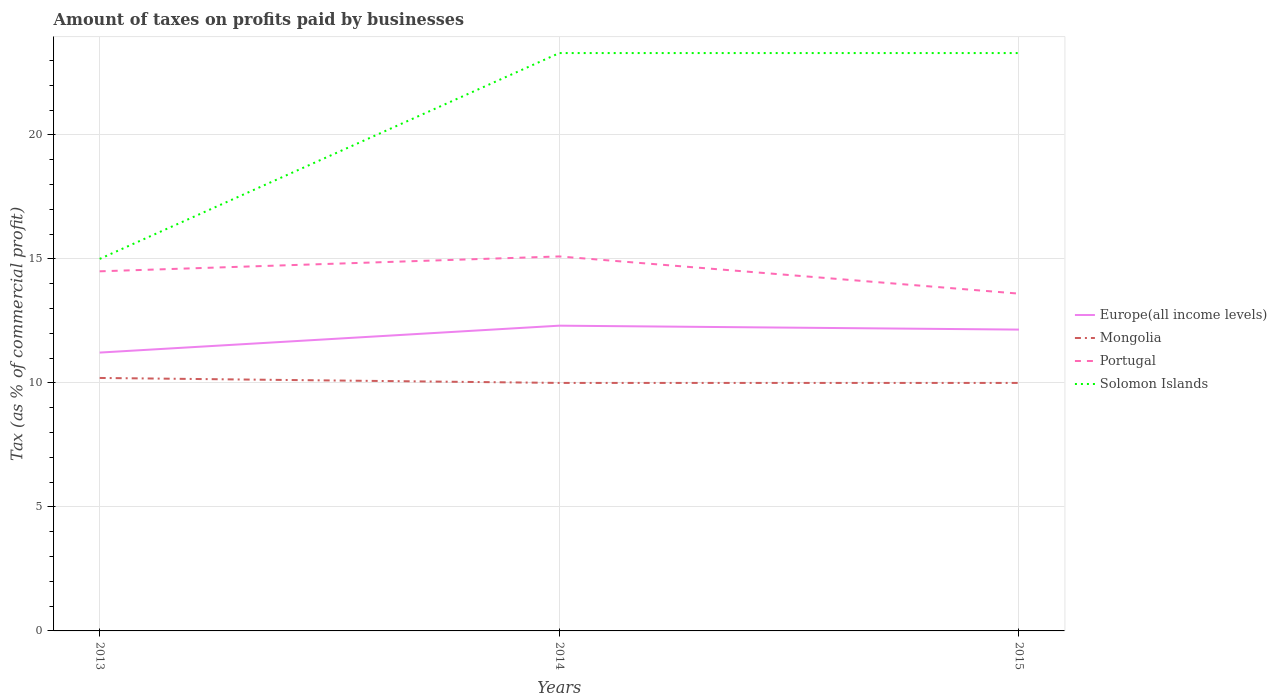Is the number of lines equal to the number of legend labels?
Offer a terse response. Yes. In which year was the percentage of taxes paid by businesses in Mongolia maximum?
Provide a short and direct response. 2014. What is the total percentage of taxes paid by businesses in Mongolia in the graph?
Give a very brief answer. 0.2. What is the difference between the highest and the second highest percentage of taxes paid by businesses in Mongolia?
Offer a terse response. 0.2. Is the percentage of taxes paid by businesses in Solomon Islands strictly greater than the percentage of taxes paid by businesses in Europe(all income levels) over the years?
Ensure brevity in your answer.  No. How many lines are there?
Provide a succinct answer. 4. How many years are there in the graph?
Your response must be concise. 3. What is the difference between two consecutive major ticks on the Y-axis?
Make the answer very short. 5. Are the values on the major ticks of Y-axis written in scientific E-notation?
Your answer should be compact. No. Does the graph contain any zero values?
Keep it short and to the point. No. How many legend labels are there?
Offer a terse response. 4. What is the title of the graph?
Your answer should be very brief. Amount of taxes on profits paid by businesses. What is the label or title of the X-axis?
Offer a terse response. Years. What is the label or title of the Y-axis?
Make the answer very short. Tax (as % of commercial profit). What is the Tax (as % of commercial profit) in Europe(all income levels) in 2013?
Provide a succinct answer. 11.22. What is the Tax (as % of commercial profit) of Portugal in 2013?
Provide a short and direct response. 14.5. What is the Tax (as % of commercial profit) in Europe(all income levels) in 2014?
Ensure brevity in your answer.  12.31. What is the Tax (as % of commercial profit) of Mongolia in 2014?
Your answer should be compact. 10. What is the Tax (as % of commercial profit) of Solomon Islands in 2014?
Your answer should be very brief. 23.3. What is the Tax (as % of commercial profit) in Europe(all income levels) in 2015?
Provide a succinct answer. 12.15. What is the Tax (as % of commercial profit) of Mongolia in 2015?
Keep it short and to the point. 10. What is the Tax (as % of commercial profit) of Portugal in 2015?
Your answer should be very brief. 13.6. What is the Tax (as % of commercial profit) of Solomon Islands in 2015?
Keep it short and to the point. 23.3. Across all years, what is the maximum Tax (as % of commercial profit) in Europe(all income levels)?
Offer a very short reply. 12.31. Across all years, what is the maximum Tax (as % of commercial profit) in Solomon Islands?
Offer a very short reply. 23.3. Across all years, what is the minimum Tax (as % of commercial profit) in Europe(all income levels)?
Make the answer very short. 11.22. Across all years, what is the minimum Tax (as % of commercial profit) of Mongolia?
Your answer should be compact. 10. What is the total Tax (as % of commercial profit) in Europe(all income levels) in the graph?
Your response must be concise. 35.68. What is the total Tax (as % of commercial profit) of Mongolia in the graph?
Your response must be concise. 30.2. What is the total Tax (as % of commercial profit) of Portugal in the graph?
Your response must be concise. 43.2. What is the total Tax (as % of commercial profit) in Solomon Islands in the graph?
Keep it short and to the point. 61.6. What is the difference between the Tax (as % of commercial profit) in Europe(all income levels) in 2013 and that in 2014?
Your response must be concise. -1.08. What is the difference between the Tax (as % of commercial profit) of Mongolia in 2013 and that in 2014?
Keep it short and to the point. 0.2. What is the difference between the Tax (as % of commercial profit) in Solomon Islands in 2013 and that in 2014?
Offer a very short reply. -8.3. What is the difference between the Tax (as % of commercial profit) in Europe(all income levels) in 2013 and that in 2015?
Ensure brevity in your answer.  -0.93. What is the difference between the Tax (as % of commercial profit) in Mongolia in 2013 and that in 2015?
Your answer should be very brief. 0.2. What is the difference between the Tax (as % of commercial profit) in Solomon Islands in 2013 and that in 2015?
Ensure brevity in your answer.  -8.3. What is the difference between the Tax (as % of commercial profit) in Europe(all income levels) in 2014 and that in 2015?
Offer a very short reply. 0.16. What is the difference between the Tax (as % of commercial profit) of Mongolia in 2014 and that in 2015?
Give a very brief answer. 0. What is the difference between the Tax (as % of commercial profit) in Portugal in 2014 and that in 2015?
Your answer should be compact. 1.5. What is the difference between the Tax (as % of commercial profit) in Solomon Islands in 2014 and that in 2015?
Offer a terse response. 0. What is the difference between the Tax (as % of commercial profit) in Europe(all income levels) in 2013 and the Tax (as % of commercial profit) in Mongolia in 2014?
Make the answer very short. 1.22. What is the difference between the Tax (as % of commercial profit) in Europe(all income levels) in 2013 and the Tax (as % of commercial profit) in Portugal in 2014?
Keep it short and to the point. -3.88. What is the difference between the Tax (as % of commercial profit) of Europe(all income levels) in 2013 and the Tax (as % of commercial profit) of Solomon Islands in 2014?
Your response must be concise. -12.08. What is the difference between the Tax (as % of commercial profit) in Mongolia in 2013 and the Tax (as % of commercial profit) in Portugal in 2014?
Your answer should be very brief. -4.9. What is the difference between the Tax (as % of commercial profit) of Mongolia in 2013 and the Tax (as % of commercial profit) of Solomon Islands in 2014?
Offer a terse response. -13.1. What is the difference between the Tax (as % of commercial profit) of Portugal in 2013 and the Tax (as % of commercial profit) of Solomon Islands in 2014?
Provide a succinct answer. -8.8. What is the difference between the Tax (as % of commercial profit) of Europe(all income levels) in 2013 and the Tax (as % of commercial profit) of Mongolia in 2015?
Your answer should be compact. 1.22. What is the difference between the Tax (as % of commercial profit) of Europe(all income levels) in 2013 and the Tax (as % of commercial profit) of Portugal in 2015?
Give a very brief answer. -2.38. What is the difference between the Tax (as % of commercial profit) in Europe(all income levels) in 2013 and the Tax (as % of commercial profit) in Solomon Islands in 2015?
Provide a succinct answer. -12.08. What is the difference between the Tax (as % of commercial profit) of Mongolia in 2013 and the Tax (as % of commercial profit) of Portugal in 2015?
Offer a very short reply. -3.4. What is the difference between the Tax (as % of commercial profit) in Portugal in 2013 and the Tax (as % of commercial profit) in Solomon Islands in 2015?
Offer a very short reply. -8.8. What is the difference between the Tax (as % of commercial profit) of Europe(all income levels) in 2014 and the Tax (as % of commercial profit) of Mongolia in 2015?
Your response must be concise. 2.31. What is the difference between the Tax (as % of commercial profit) of Europe(all income levels) in 2014 and the Tax (as % of commercial profit) of Portugal in 2015?
Ensure brevity in your answer.  -1.29. What is the difference between the Tax (as % of commercial profit) of Europe(all income levels) in 2014 and the Tax (as % of commercial profit) of Solomon Islands in 2015?
Ensure brevity in your answer.  -10.99. What is the difference between the Tax (as % of commercial profit) of Mongolia in 2014 and the Tax (as % of commercial profit) of Solomon Islands in 2015?
Your response must be concise. -13.3. What is the difference between the Tax (as % of commercial profit) in Portugal in 2014 and the Tax (as % of commercial profit) in Solomon Islands in 2015?
Keep it short and to the point. -8.2. What is the average Tax (as % of commercial profit) in Europe(all income levels) per year?
Your response must be concise. 11.89. What is the average Tax (as % of commercial profit) in Mongolia per year?
Your answer should be compact. 10.07. What is the average Tax (as % of commercial profit) of Portugal per year?
Provide a short and direct response. 14.4. What is the average Tax (as % of commercial profit) in Solomon Islands per year?
Ensure brevity in your answer.  20.53. In the year 2013, what is the difference between the Tax (as % of commercial profit) in Europe(all income levels) and Tax (as % of commercial profit) in Mongolia?
Give a very brief answer. 1.02. In the year 2013, what is the difference between the Tax (as % of commercial profit) in Europe(all income levels) and Tax (as % of commercial profit) in Portugal?
Ensure brevity in your answer.  -3.28. In the year 2013, what is the difference between the Tax (as % of commercial profit) of Europe(all income levels) and Tax (as % of commercial profit) of Solomon Islands?
Make the answer very short. -3.78. In the year 2013, what is the difference between the Tax (as % of commercial profit) in Portugal and Tax (as % of commercial profit) in Solomon Islands?
Your response must be concise. -0.5. In the year 2014, what is the difference between the Tax (as % of commercial profit) in Europe(all income levels) and Tax (as % of commercial profit) in Mongolia?
Your response must be concise. 2.31. In the year 2014, what is the difference between the Tax (as % of commercial profit) of Europe(all income levels) and Tax (as % of commercial profit) of Portugal?
Offer a very short reply. -2.79. In the year 2014, what is the difference between the Tax (as % of commercial profit) of Europe(all income levels) and Tax (as % of commercial profit) of Solomon Islands?
Provide a short and direct response. -10.99. In the year 2014, what is the difference between the Tax (as % of commercial profit) in Mongolia and Tax (as % of commercial profit) in Portugal?
Make the answer very short. -5.1. In the year 2014, what is the difference between the Tax (as % of commercial profit) of Mongolia and Tax (as % of commercial profit) of Solomon Islands?
Provide a short and direct response. -13.3. In the year 2014, what is the difference between the Tax (as % of commercial profit) in Portugal and Tax (as % of commercial profit) in Solomon Islands?
Offer a very short reply. -8.2. In the year 2015, what is the difference between the Tax (as % of commercial profit) of Europe(all income levels) and Tax (as % of commercial profit) of Mongolia?
Your answer should be compact. 2.15. In the year 2015, what is the difference between the Tax (as % of commercial profit) of Europe(all income levels) and Tax (as % of commercial profit) of Portugal?
Your response must be concise. -1.45. In the year 2015, what is the difference between the Tax (as % of commercial profit) in Europe(all income levels) and Tax (as % of commercial profit) in Solomon Islands?
Ensure brevity in your answer.  -11.15. In the year 2015, what is the difference between the Tax (as % of commercial profit) in Mongolia and Tax (as % of commercial profit) in Portugal?
Provide a succinct answer. -3.6. What is the ratio of the Tax (as % of commercial profit) of Europe(all income levels) in 2013 to that in 2014?
Offer a very short reply. 0.91. What is the ratio of the Tax (as % of commercial profit) of Portugal in 2013 to that in 2014?
Offer a terse response. 0.96. What is the ratio of the Tax (as % of commercial profit) of Solomon Islands in 2013 to that in 2014?
Make the answer very short. 0.64. What is the ratio of the Tax (as % of commercial profit) of Europe(all income levels) in 2013 to that in 2015?
Provide a short and direct response. 0.92. What is the ratio of the Tax (as % of commercial profit) in Mongolia in 2013 to that in 2015?
Provide a succinct answer. 1.02. What is the ratio of the Tax (as % of commercial profit) of Portugal in 2013 to that in 2015?
Offer a terse response. 1.07. What is the ratio of the Tax (as % of commercial profit) in Solomon Islands in 2013 to that in 2015?
Provide a short and direct response. 0.64. What is the ratio of the Tax (as % of commercial profit) in Portugal in 2014 to that in 2015?
Give a very brief answer. 1.11. What is the ratio of the Tax (as % of commercial profit) in Solomon Islands in 2014 to that in 2015?
Keep it short and to the point. 1. What is the difference between the highest and the second highest Tax (as % of commercial profit) of Europe(all income levels)?
Offer a terse response. 0.16. What is the difference between the highest and the second highest Tax (as % of commercial profit) of Mongolia?
Your response must be concise. 0.2. What is the difference between the highest and the second highest Tax (as % of commercial profit) of Portugal?
Offer a very short reply. 0.6. What is the difference between the highest and the second highest Tax (as % of commercial profit) in Solomon Islands?
Provide a short and direct response. 0. What is the difference between the highest and the lowest Tax (as % of commercial profit) of Europe(all income levels)?
Keep it short and to the point. 1.08. 